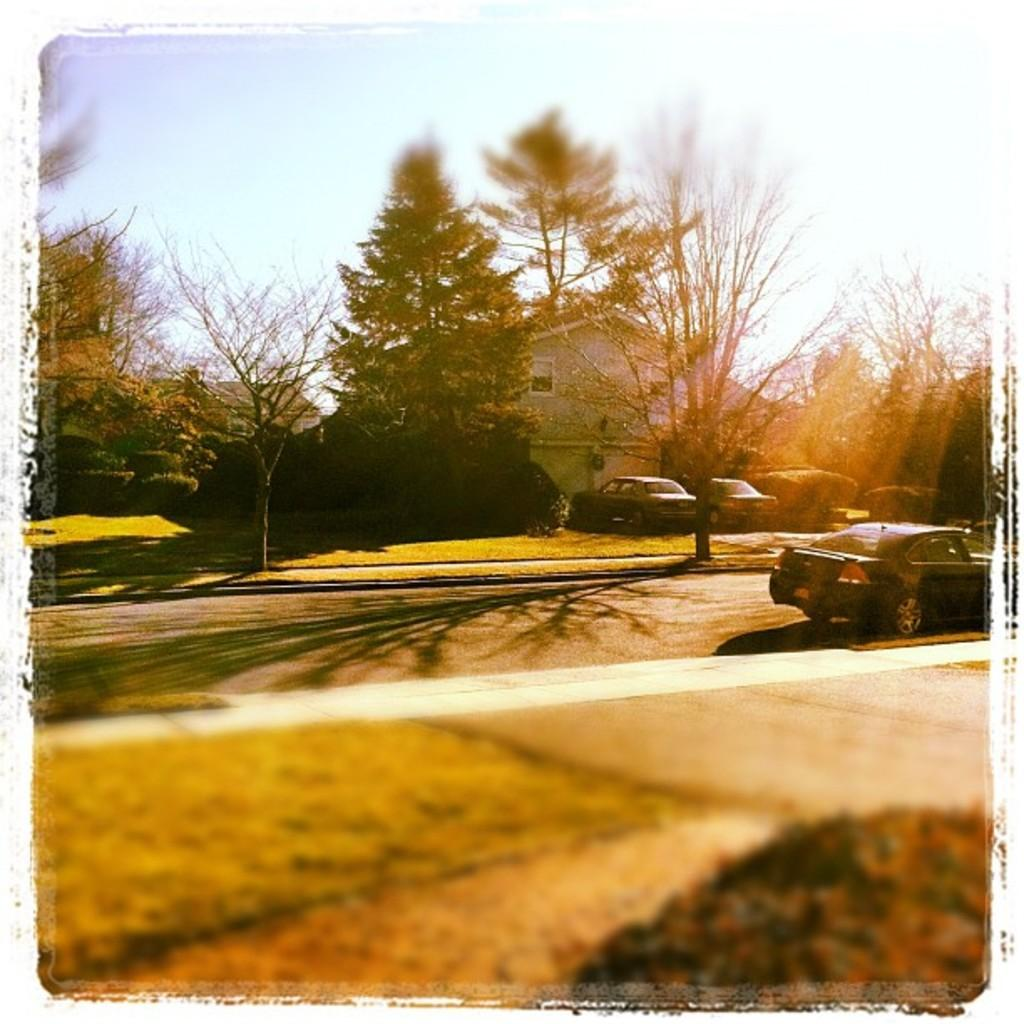What is the main subject of the image? There is a car on the road in the image. Are there any other cars visible in the image? Yes, there are two cars parked in front of a house in the image. What can be seen in the background of the image? There are trees and the sky visible in the background of the image. What type of sack is hanging from the tree in the image? There is no sack hanging from a tree in the image; only trees and the sky are visible in the background. 